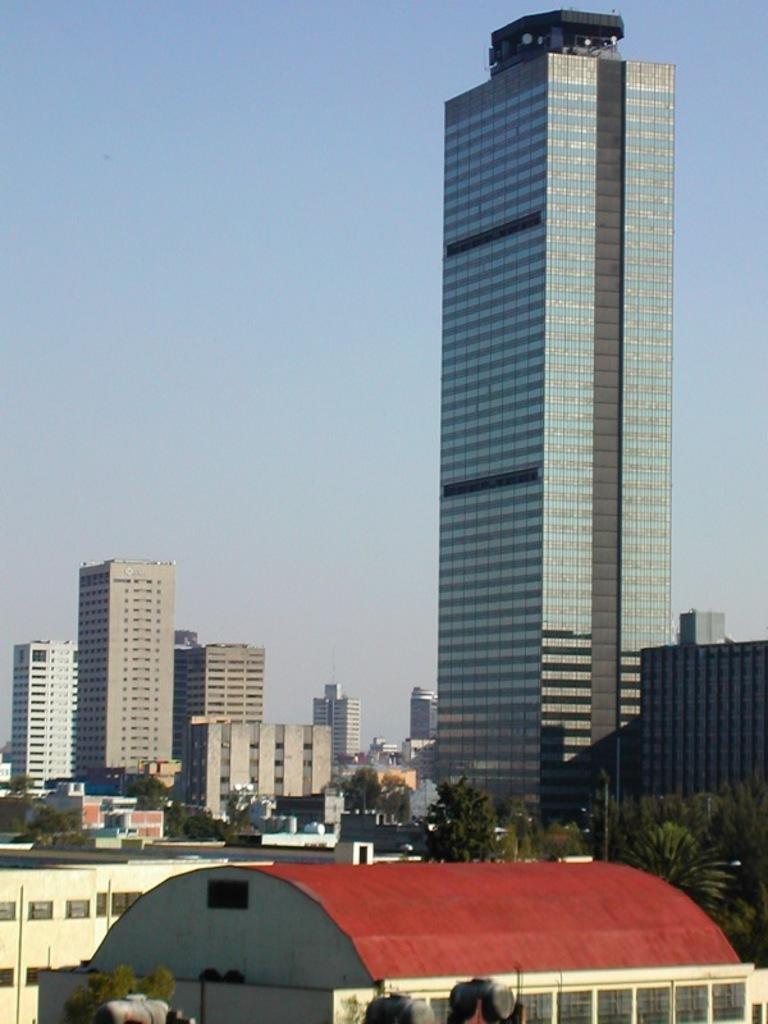How would you summarize this image in a sentence or two? In this image we can see buildings, trees and poles. At the top of the image, we can see the sky. 